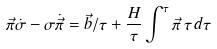<formula> <loc_0><loc_0><loc_500><loc_500>\vec { \pi } \dot { \sigma } - \sigma \dot { \vec { \pi } } = \vec { b } / \tau + { \frac { H } { \tau } } \int ^ { \tau } \vec { \pi } \, \tau \, d \tau</formula> 